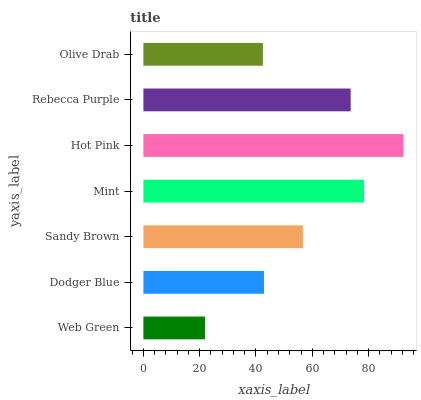Is Web Green the minimum?
Answer yes or no. Yes. Is Hot Pink the maximum?
Answer yes or no. Yes. Is Dodger Blue the minimum?
Answer yes or no. No. Is Dodger Blue the maximum?
Answer yes or no. No. Is Dodger Blue greater than Web Green?
Answer yes or no. Yes. Is Web Green less than Dodger Blue?
Answer yes or no. Yes. Is Web Green greater than Dodger Blue?
Answer yes or no. No. Is Dodger Blue less than Web Green?
Answer yes or no. No. Is Sandy Brown the high median?
Answer yes or no. Yes. Is Sandy Brown the low median?
Answer yes or no. Yes. Is Web Green the high median?
Answer yes or no. No. Is Web Green the low median?
Answer yes or no. No. 